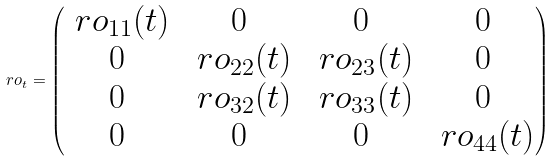Convert formula to latex. <formula><loc_0><loc_0><loc_500><loc_500>\ r o _ { t } = \begin{pmatrix} \ r o _ { 1 1 } ( t ) & 0 & 0 & 0 \\ 0 & \ r o _ { 2 2 } ( t ) & \ r o _ { 2 3 } ( t ) & 0 \\ 0 & \ r o _ { 3 2 } ( t ) & \ r o _ { 3 3 } ( t ) & 0 \\ 0 & 0 & 0 & \ r o _ { 4 4 } ( t ) \end{pmatrix}</formula> 